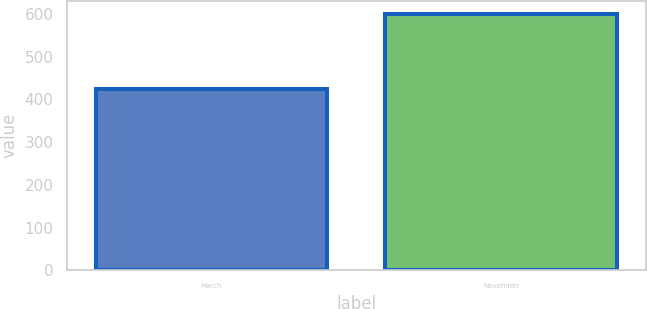Convert chart. <chart><loc_0><loc_0><loc_500><loc_500><bar_chart><fcel>March<fcel>November<nl><fcel>425<fcel>600<nl></chart> 